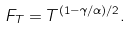Convert formula to latex. <formula><loc_0><loc_0><loc_500><loc_500>F _ { T } = T ^ { ( 1 - \gamma / \alpha ) / 2 } .</formula> 